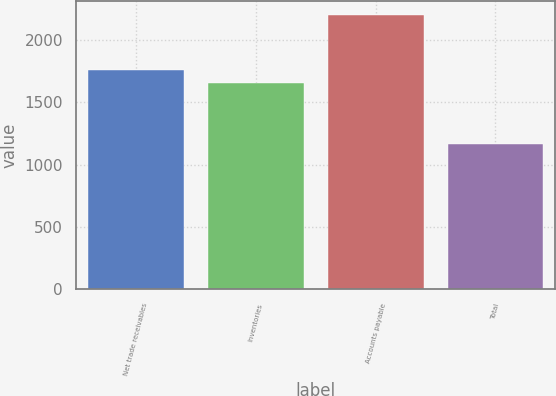Convert chart. <chart><loc_0><loc_0><loc_500><loc_500><bar_chart><fcel>Net trade receivables<fcel>Inventories<fcel>Accounts payable<fcel>Total<nl><fcel>1760.9<fcel>1657<fcel>2202<fcel>1163<nl></chart> 